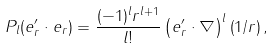Convert formula to latex. <formula><loc_0><loc_0><loc_500><loc_500>P _ { l } ( { e } _ { r } ^ { \prime } \cdot { e } _ { r } ) = \frac { ( - 1 ) ^ { l } r ^ { l + 1 } } { l ! } \left ( { e } _ { r } ^ { \prime } \cdot \nabla \right ) ^ { l } \left ( 1 / r \right ) ,</formula> 